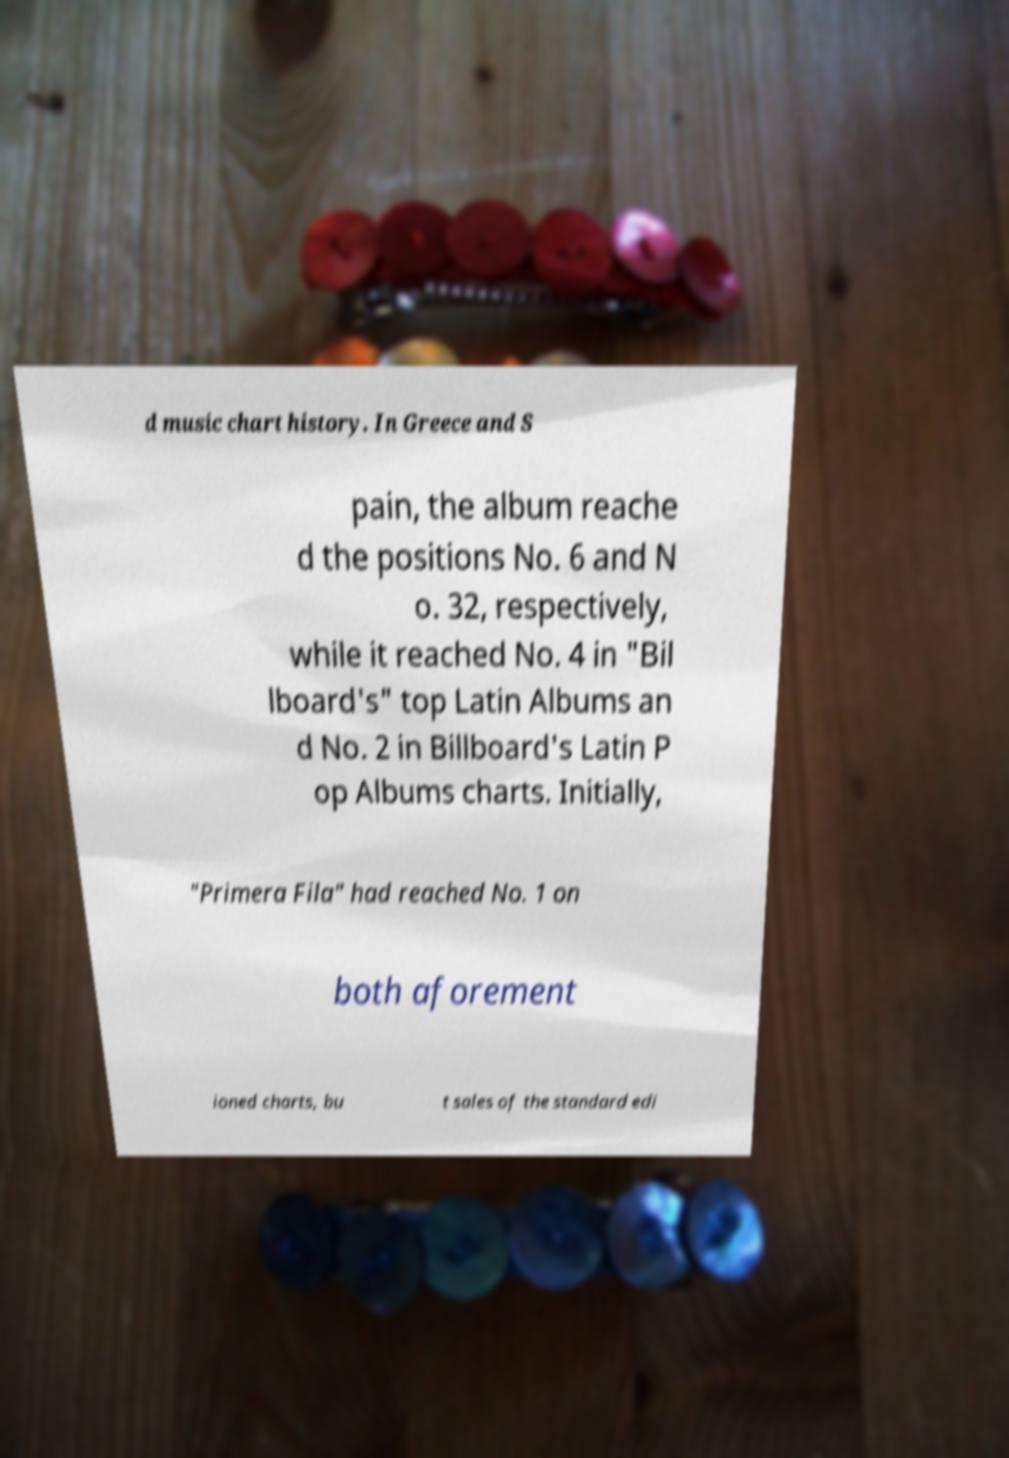Please read and relay the text visible in this image. What does it say? d music chart history. In Greece and S pain, the album reache d the positions No. 6 and N o. 32, respectively, while it reached No. 4 in "Bil lboard's" top Latin Albums an d No. 2 in Billboard's Latin P op Albums charts. Initially, "Primera Fila" had reached No. 1 on both aforement ioned charts, bu t sales of the standard edi 